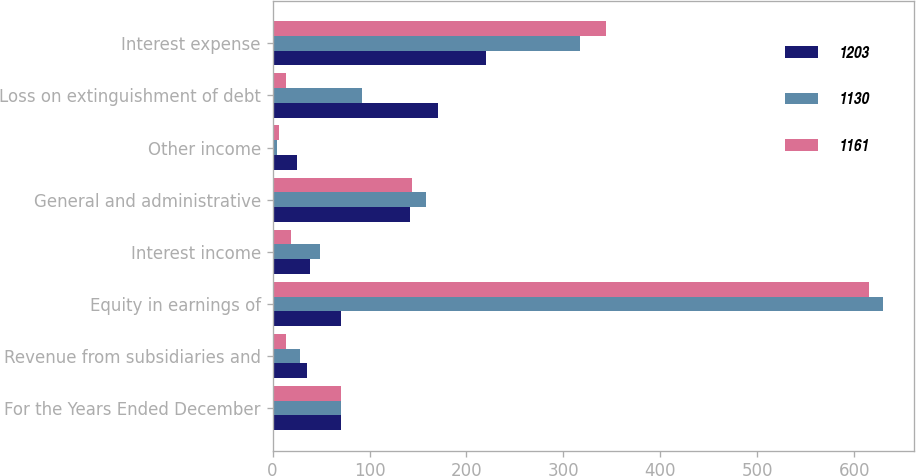<chart> <loc_0><loc_0><loc_500><loc_500><stacked_bar_chart><ecel><fcel>For the Years Ended December<fcel>Revenue from subsidiaries and<fcel>Equity in earnings of<fcel>Interest income<fcel>General and administrative<fcel>Other income<fcel>Loss on extinguishment of debt<fcel>Interest expense<nl><fcel>1203<fcel>70.5<fcel>36<fcel>70.5<fcel>39<fcel>142<fcel>25<fcel>171<fcel>220<nl><fcel>1130<fcel>70.5<fcel>28<fcel>630<fcel>49<fcel>158<fcel>5<fcel>92<fcel>317<nl><fcel>1161<fcel>70.5<fcel>14<fcel>615<fcel>19<fcel>144<fcel>7<fcel>14<fcel>344<nl></chart> 